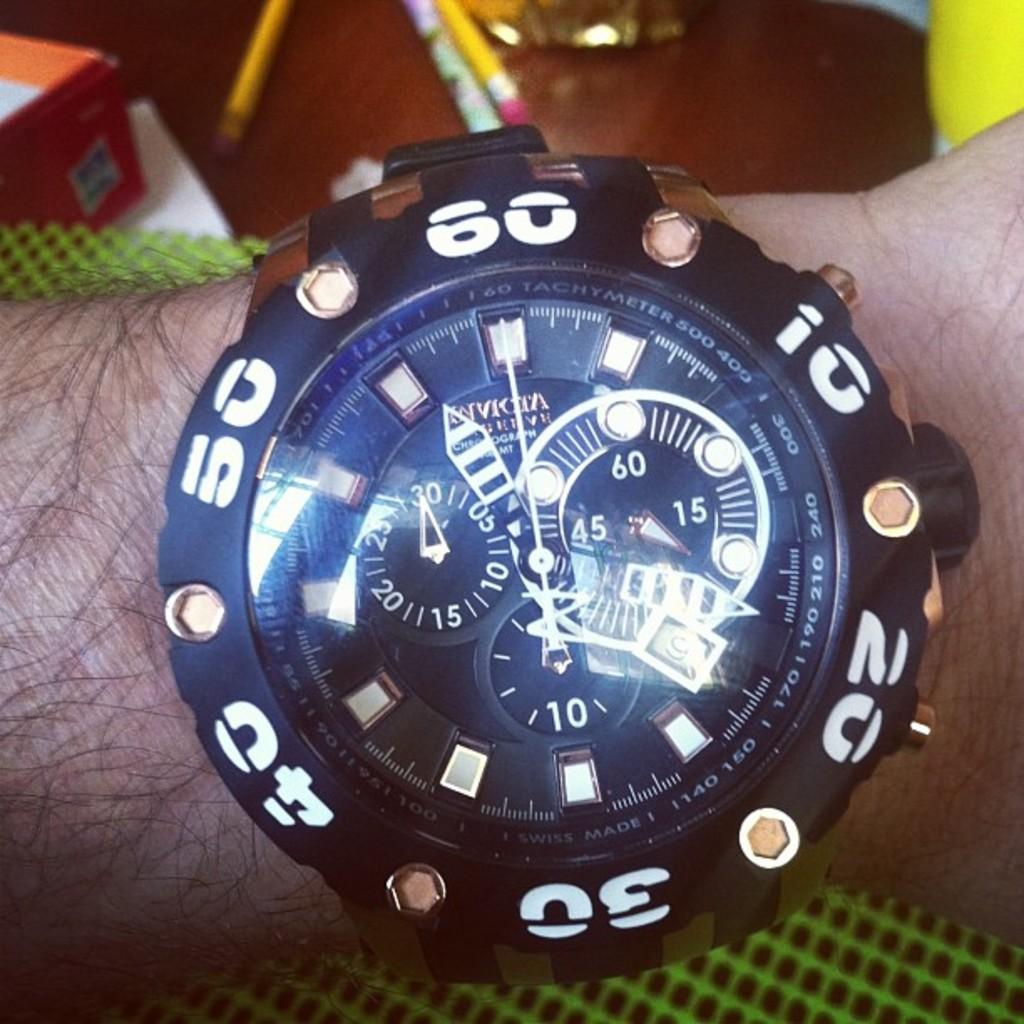<image>
Share a concise interpretation of the image provided. person wearing a wristwatch with the numbe 20 on the right. 